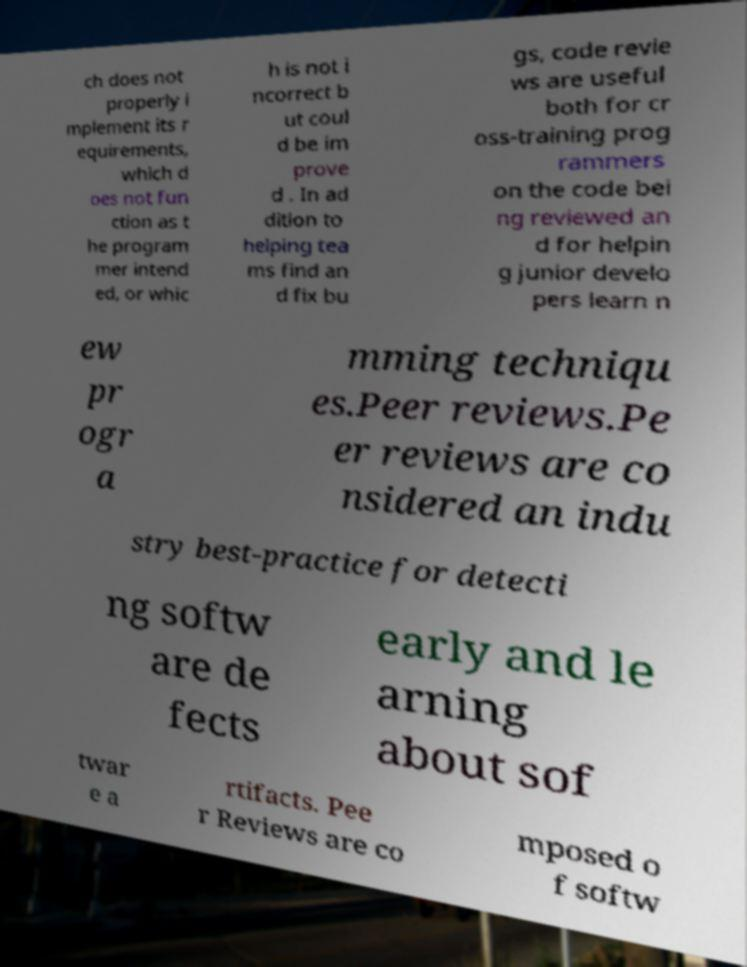What messages or text are displayed in this image? I need them in a readable, typed format. ch does not properly i mplement its r equirements, which d oes not fun ction as t he program mer intend ed, or whic h is not i ncorrect b ut coul d be im prove d . In ad dition to helping tea ms find an d fix bu gs, code revie ws are useful both for cr oss-training prog rammers on the code bei ng reviewed an d for helpin g junior develo pers learn n ew pr ogr a mming techniqu es.Peer reviews.Pe er reviews are co nsidered an indu stry best-practice for detecti ng softw are de fects early and le arning about sof twar e a rtifacts. Pee r Reviews are co mposed o f softw 